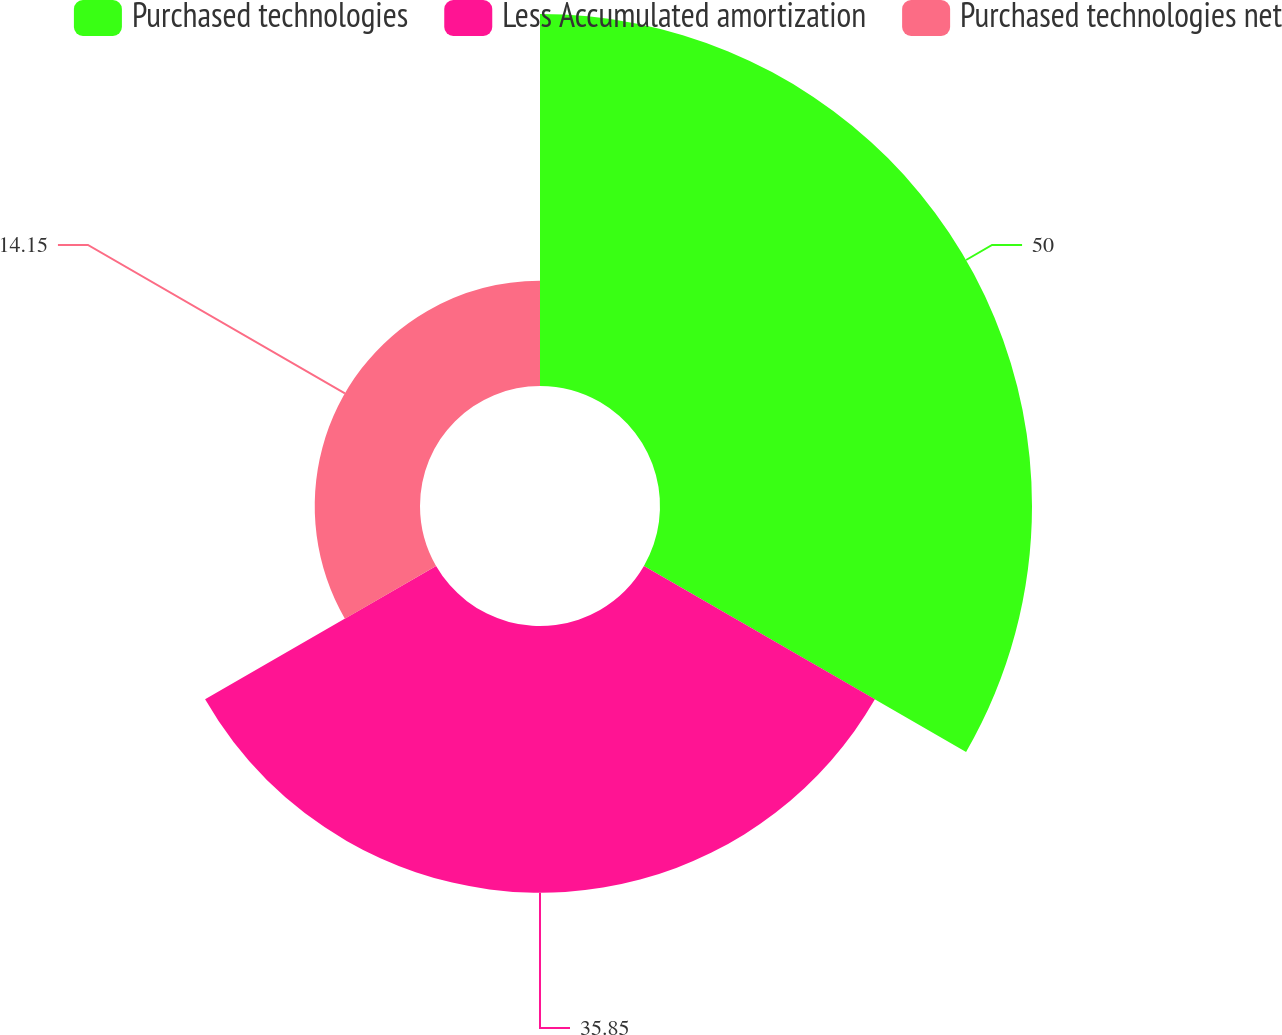Convert chart to OTSL. <chart><loc_0><loc_0><loc_500><loc_500><pie_chart><fcel>Purchased technologies<fcel>Less Accumulated amortization<fcel>Purchased technologies net<nl><fcel>50.0%<fcel>35.85%<fcel>14.15%<nl></chart> 